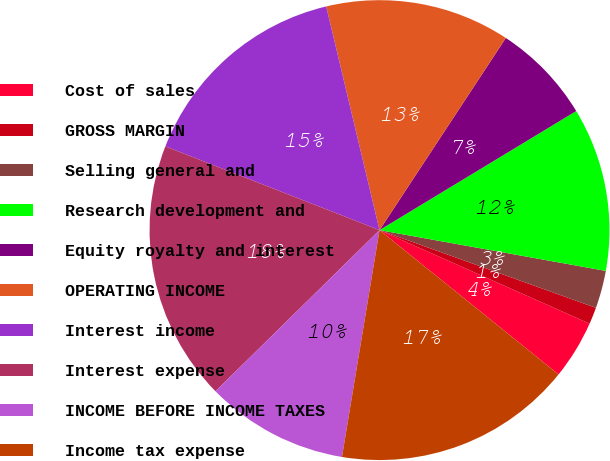Convert chart to OTSL. <chart><loc_0><loc_0><loc_500><loc_500><pie_chart><fcel>Cost of sales<fcel>GROSS MARGIN<fcel>Selling general and<fcel>Research development and<fcel>Equity royalty and interest<fcel>OPERATING INCOME<fcel>Interest income<fcel>Interest expense<fcel>INCOME BEFORE INCOME TAXES<fcel>Income tax expense<nl><fcel>4.13%<fcel>1.18%<fcel>2.65%<fcel>11.5%<fcel>7.08%<fcel>12.98%<fcel>15.34%<fcel>18.29%<fcel>10.03%<fcel>16.81%<nl></chart> 